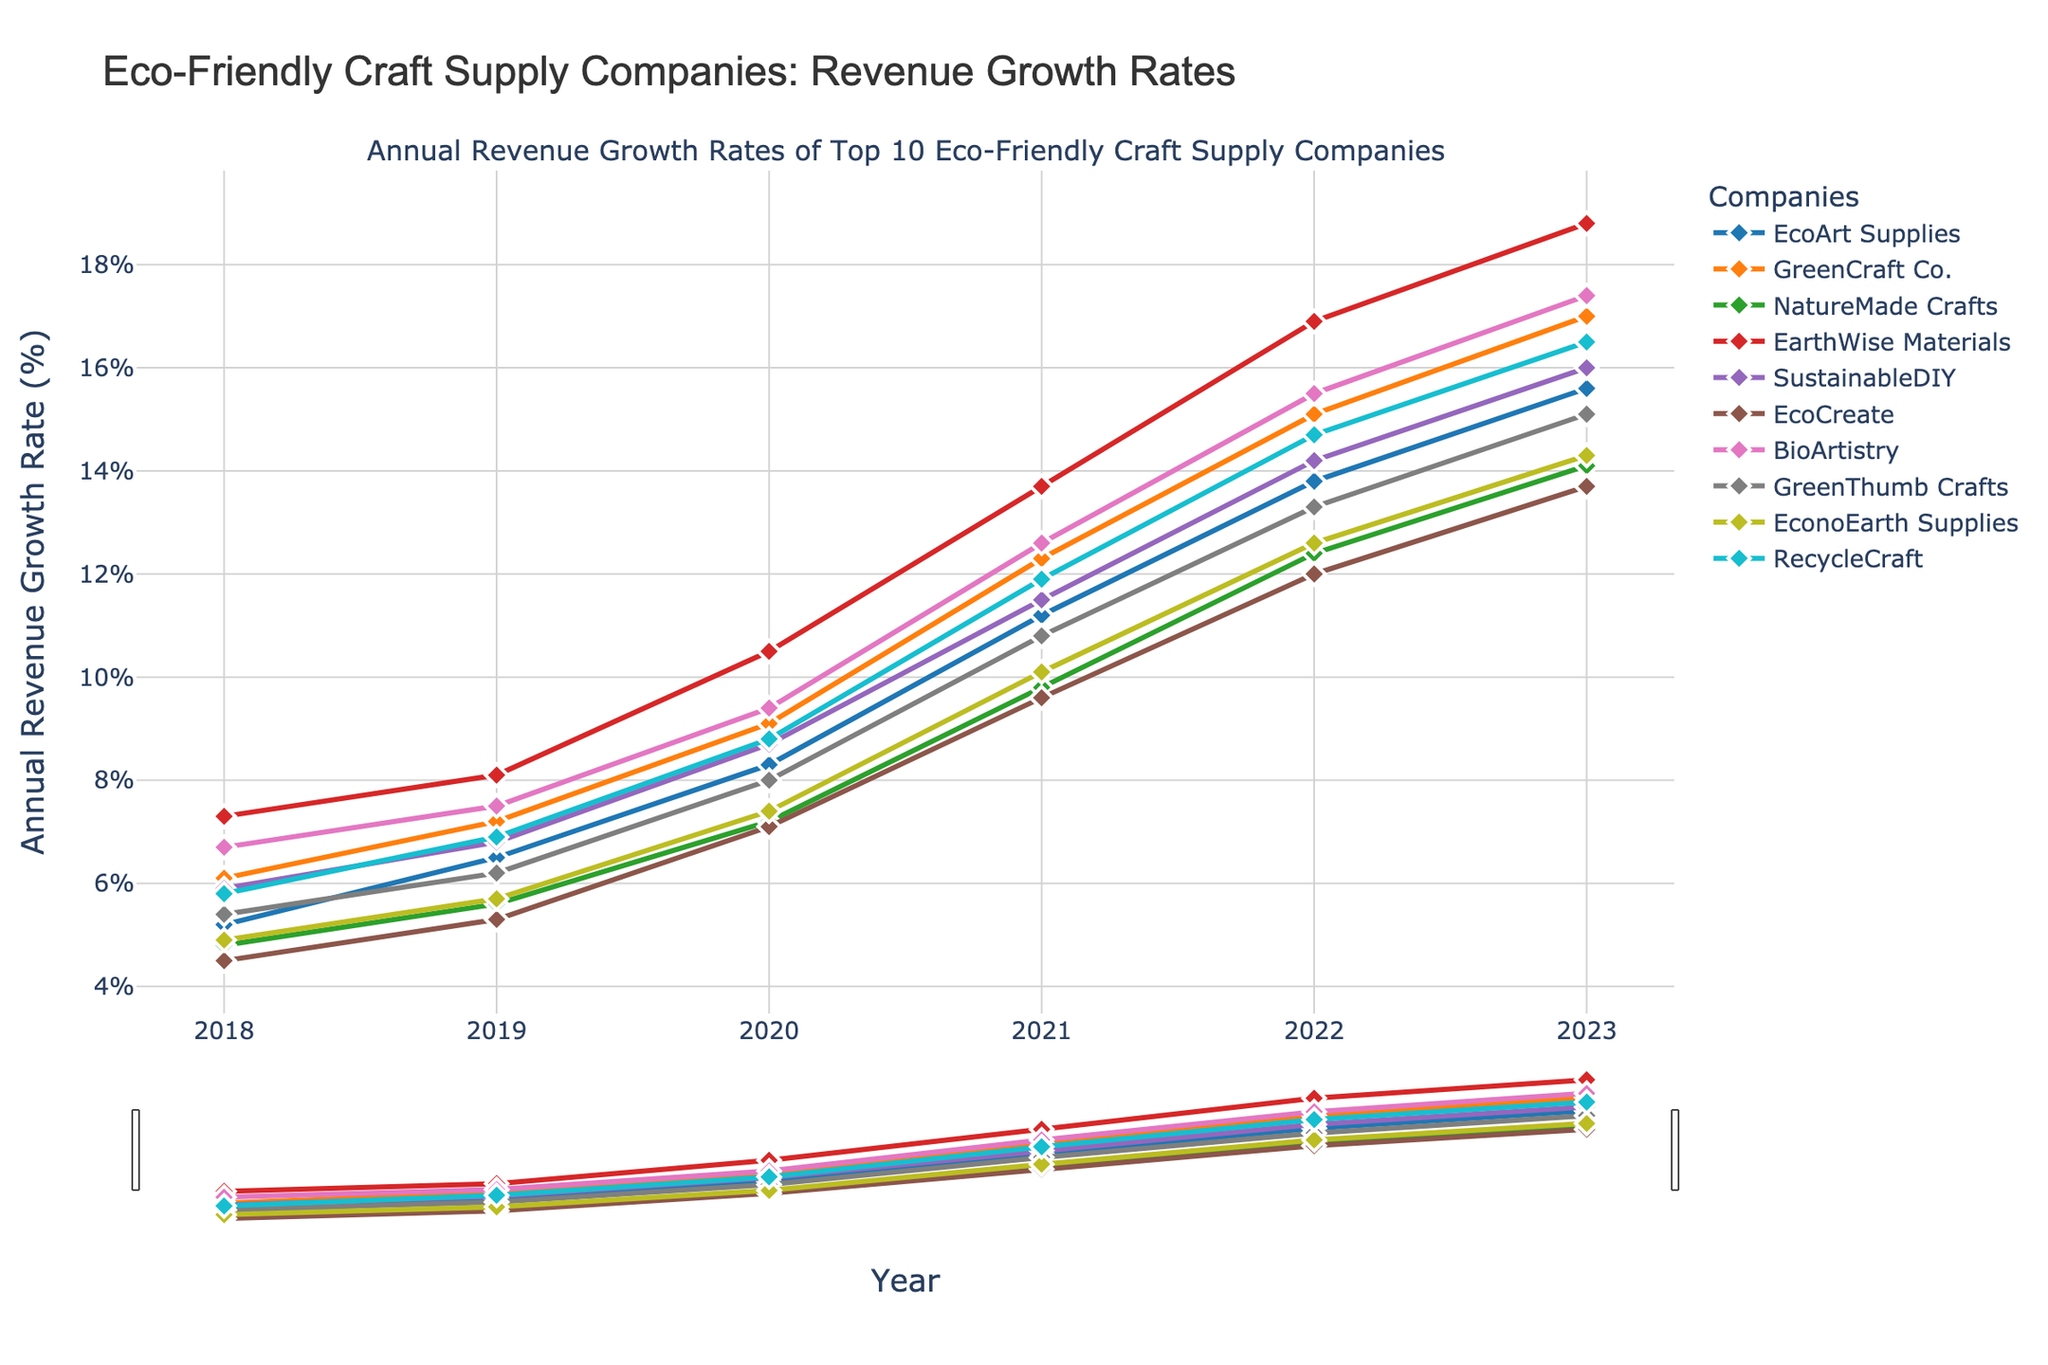What's the annual revenue growth rate of GreenCraft Co. in 2020? To find the annual revenue growth rate of GreenCraft Co. in 2020, refer to the line corresponding to GreenCraft Co. (represented in a specific color and marker) and locate the data point for the year 2020.
Answer: 9.1% Which company had the highest revenue growth rate in 2023? To find the company with the highest revenue growth rate in 2023, compare the data points for 2023 across all companies. The company with the highest y-value in 2023 is the answer.
Answer: NatureMade Crafts By how much did the revenue growth rate of EarthWise Materials increase from 2018 to 2023? Subtract Earth's 2018 revenue growth rate from its 2023 revenue growth rate. EarthWise Materials' growth rate in 2023 is 18.8, and in 2018 it was 7.3. Calculate the difference: 18.8 - 7.3.
Answer: 11.5% Which two companies had the closest revenue growth rates in 2021, and what are those rates? To determine which two companies had the closest revenue growth rates in 2021, compare the data points for the year 2021 for each company, looking for the smallest difference.
Answer: EcoArt Supplies and BioArtistry with rates of 11.2% and 12.6% respectively What is the average revenue growth rate of SustainableDIY over the six years shown? Add the annual revenue growth rates of SustainableDIY for each year and divide the sum by the number of years (6): (5.9 + 6.8 + 8.7 + 11.5 + 14.2 + 16.0) / 6.
Answer: 10.52% Which company had the most consistent (least variable) growth rates over the six years? To determine which company had the most consistent growth, compare the fluctuations in their annual growth rates over the years. The company with the smallest range (difference between the highest and lowest values) is the most consistent.
Answer: EconoEarth Supplies In which year did EcoCreate have the highest annual revenue growth rate, and what was the rate? Examine EcoCreate's data points across the years to identify in which year the highest data point occurs. The highest rate is observed in 2023.
Answer: 13.7% Between 2019 and 2020, which company experienced the greatest increase in its annual revenue growth rate? Calculate the differences in growth rates between 2019 and 2020 for each company, and identify the company with the largest difference. EarthWise Materials had the largest increase: 10.5 - 8.1 = 2.4
Answer: EarthWise Materials What is the combined annual revenue growth rate of all companies in 2022? Sum the growth rates of all companies in 2022: 13.8 + 15.1 + 12.4 + 16.9 + 14.2 + 12.0 + 15.5 + 13.3 + 12.6 + 14.7.
Answer: 140.5% Compare the revenue growth rates of EcoArt Supplies and RecycleCraft in 2021. Which one had a higher rate and by how much? Check the data points for EcoArt Supplies and RecycleCraft for 2021. Subtract EcoArt Supplies' rate from RecycleCraft's rate to determine the difference (11.9 - 11.2 = 0.7).
Answer: RecycleCraft by 0.7% 